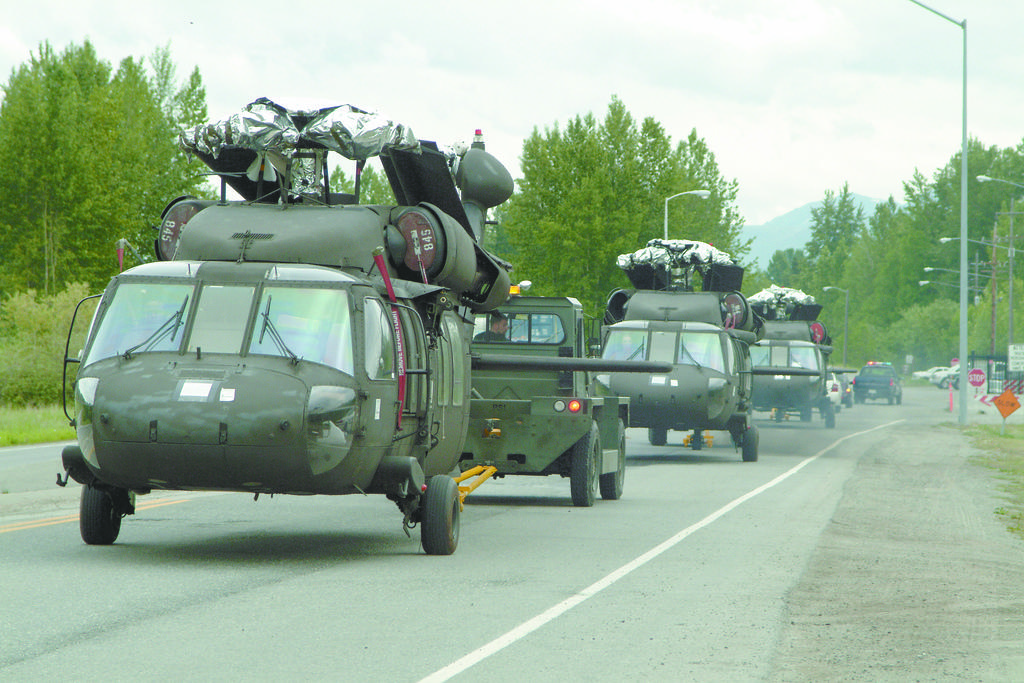What is happening on the road in the image? Vehicles are passing on the road in the image. What structures are visible along the road? Light poles are visible in the image. What type of information might be conveyed by the objects on the roadside? Sign boards are present in the image, which might convey information or directions. What type of vegetation is visible in the image? Trees and grass are visible in the image. What type of landscape can be seen in the background? Hills are visible in the image, and the sky is also visible. What type of grape is being sold at the roadside stand in the image? There is no roadside stand or grapes present in the image. How much does it cost to use the bells in the image? There are no bells present in the image, so it is not possible to determine the cost of using them. 